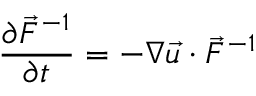Convert formula to latex. <formula><loc_0><loc_0><loc_500><loc_500>\frac { \partial \vec { F } ^ { - 1 } } { \partial t } = - \nabla \vec { u } \cdot \vec { F } ^ { - 1 }</formula> 